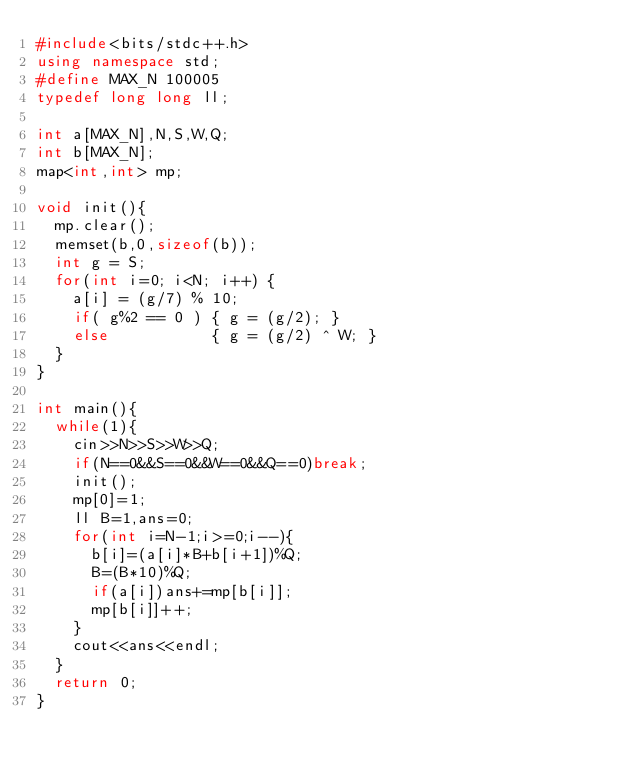Convert code to text. <code><loc_0><loc_0><loc_500><loc_500><_C++_>#include<bits/stdc++.h>
using namespace std;
#define MAX_N 100005
typedef long long ll;

int a[MAX_N],N,S,W,Q;
int b[MAX_N];
map<int,int> mp;

void init(){
  mp.clear();
  memset(b,0,sizeof(b));
  int g = S;
  for(int i=0; i<N; i++) {
    a[i] = (g/7) % 10;
    if( g%2 == 0 ) { g = (g/2); }
    else           { g = (g/2) ^ W; }
  }
}

int main(){
  while(1){
    cin>>N>>S>>W>>Q;
    if(N==0&&S==0&&W==0&&Q==0)break;
    init();
    mp[0]=1;
    ll B=1,ans=0;
    for(int i=N-1;i>=0;i--){
      b[i]=(a[i]*B+b[i+1])%Q;
      B=(B*10)%Q;
      if(a[i])ans+=mp[b[i]];
      mp[b[i]]++;
    }
    cout<<ans<<endl;
  }
  return 0;
}</code> 